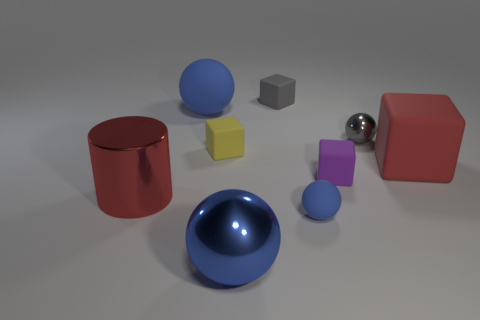Subtract all green blocks. How many blue balls are left? 3 Subtract 1 cubes. How many cubes are left? 3 Subtract all balls. How many objects are left? 5 Add 6 tiny gray shiny spheres. How many tiny gray shiny spheres exist? 7 Subtract 0 cyan cylinders. How many objects are left? 9 Subtract all large blocks. Subtract all purple objects. How many objects are left? 7 Add 4 big blue spheres. How many big blue spheres are left? 6 